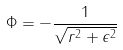Convert formula to latex. <formula><loc_0><loc_0><loc_500><loc_500>\Phi = - \frac { 1 } { \sqrt { r ^ { 2 } + \epsilon ^ { 2 } } }</formula> 